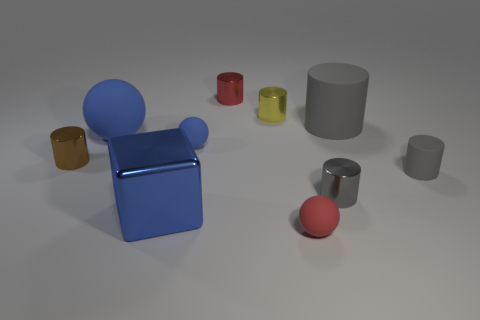Which objects in the image have cylindrical shapes? The objects with cylindrical shapes are the two larger gray cylinders and the smaller red, yellow, and silver cylinders. 